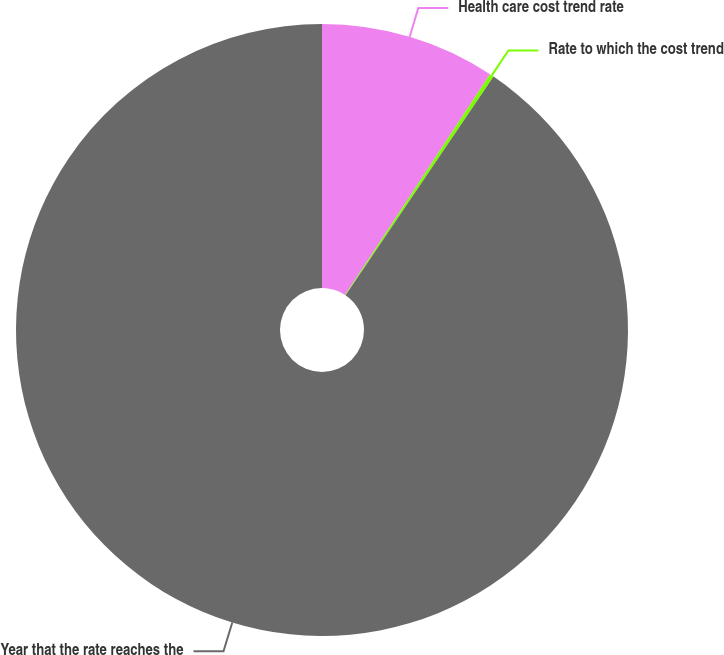Convert chart. <chart><loc_0><loc_0><loc_500><loc_500><pie_chart><fcel>Health care cost trend rate<fcel>Rate to which the cost trend<fcel>Year that the rate reaches the<nl><fcel>9.25%<fcel>0.22%<fcel>90.52%<nl></chart> 